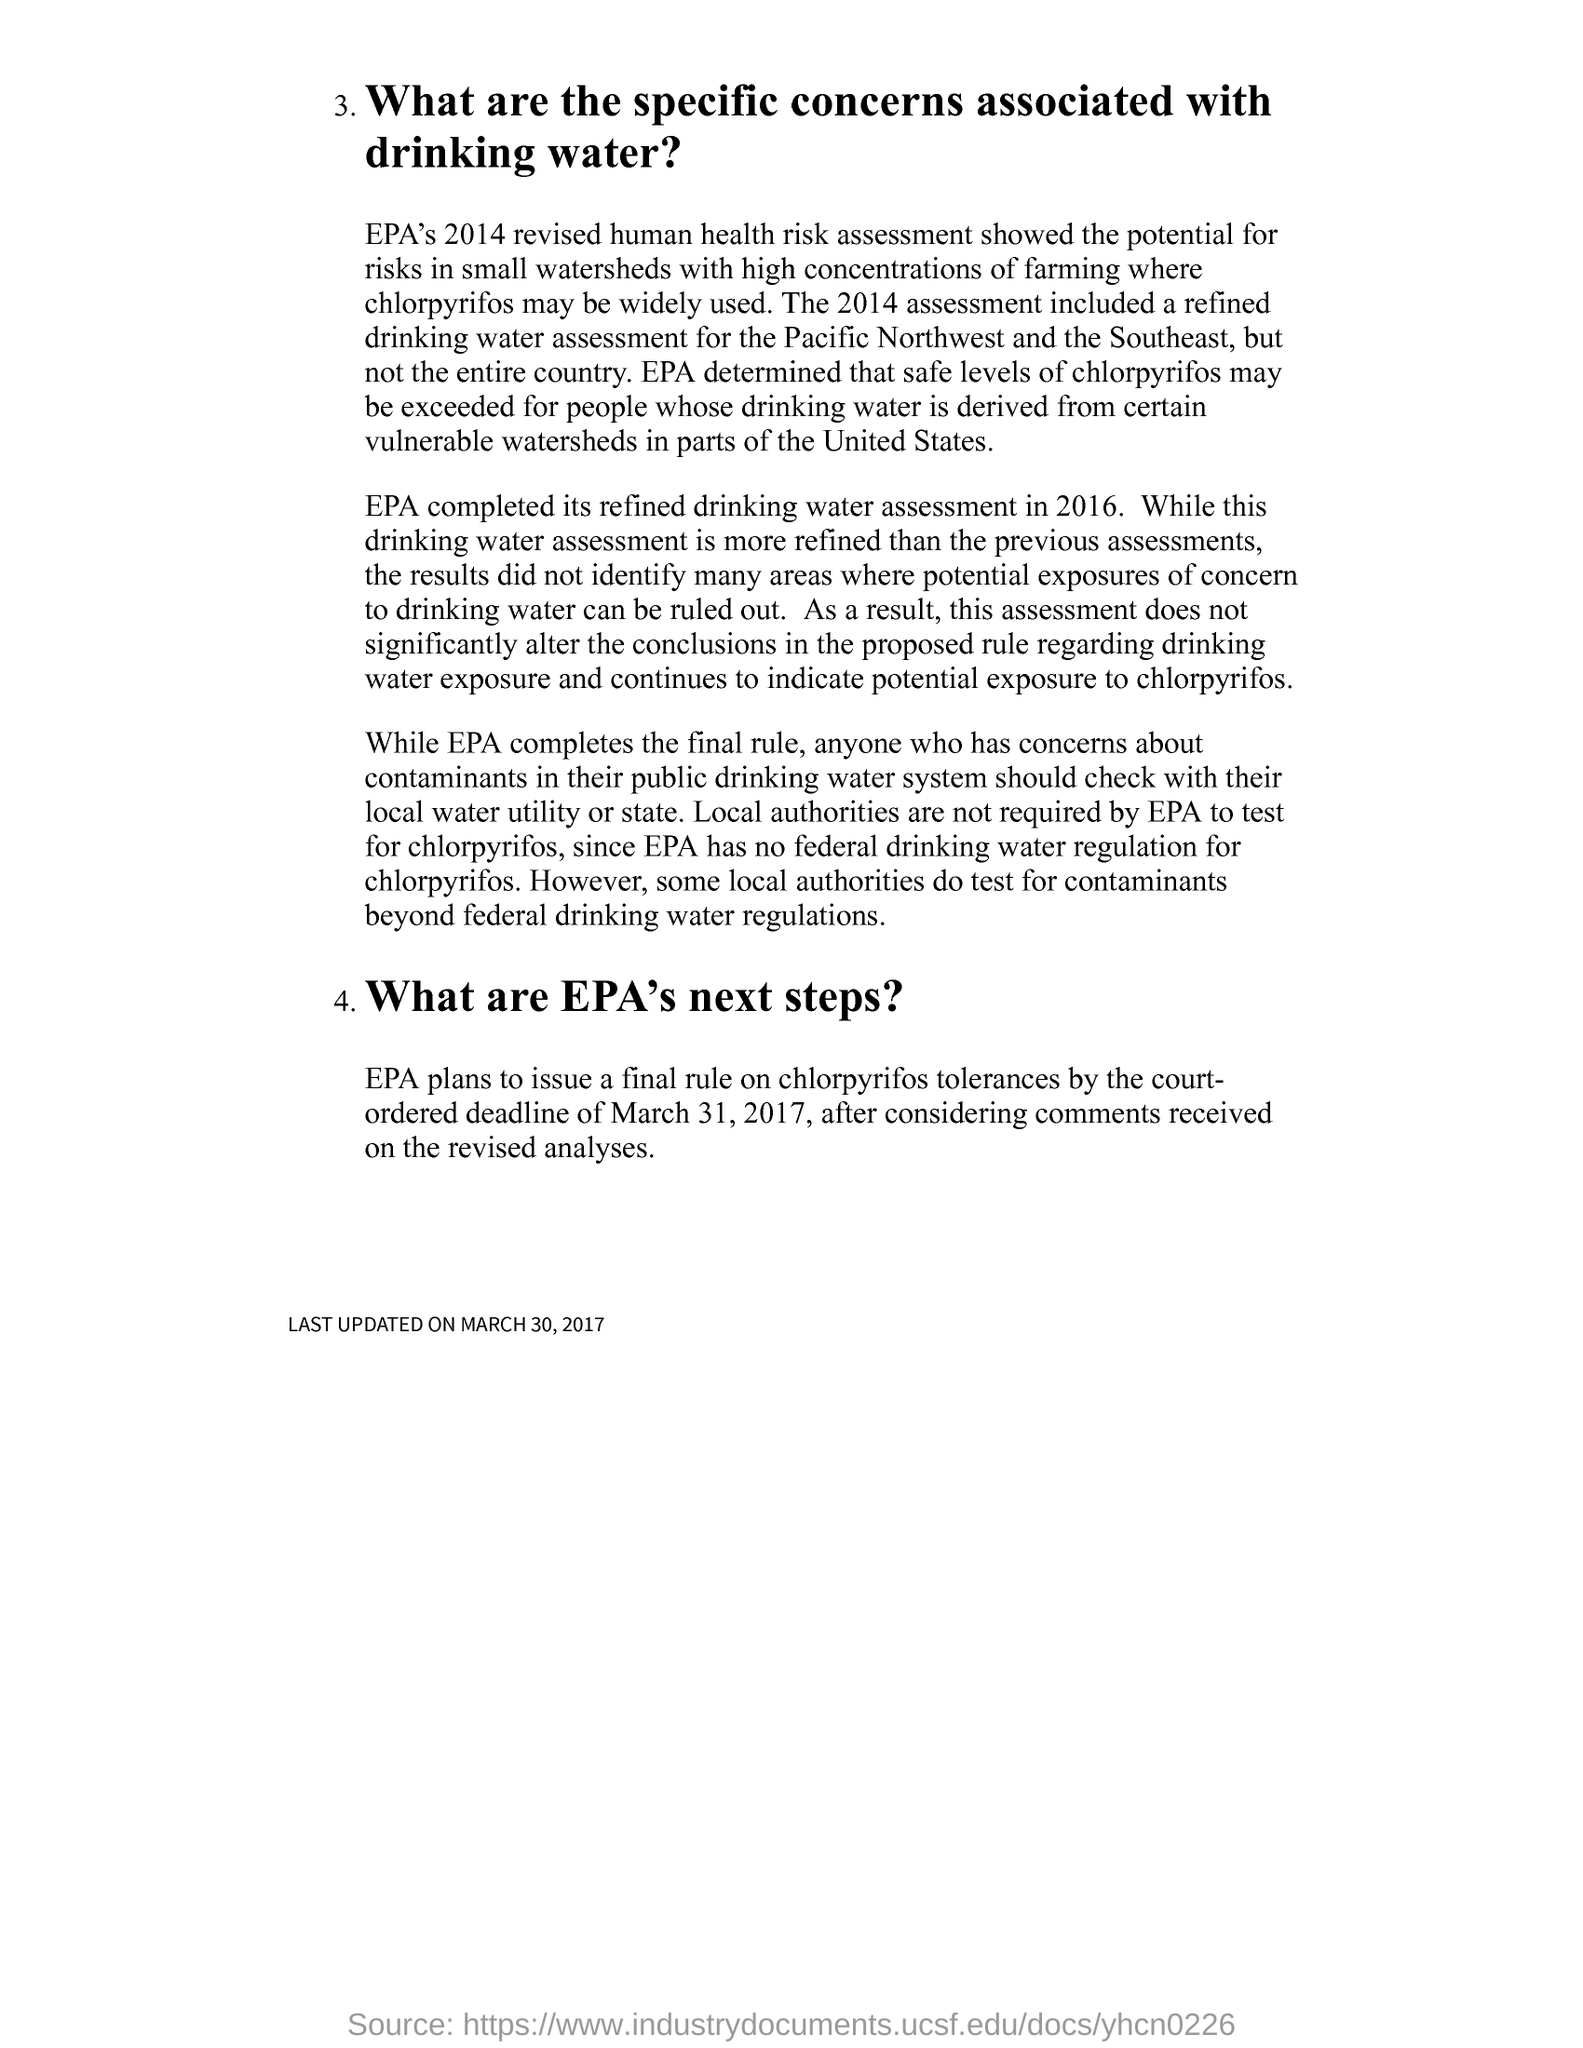Give some essential details in this illustration. On March 31, 2017, the court-ordered deadline for issuing a final rule on chlorpyrifos tolerances passed. 